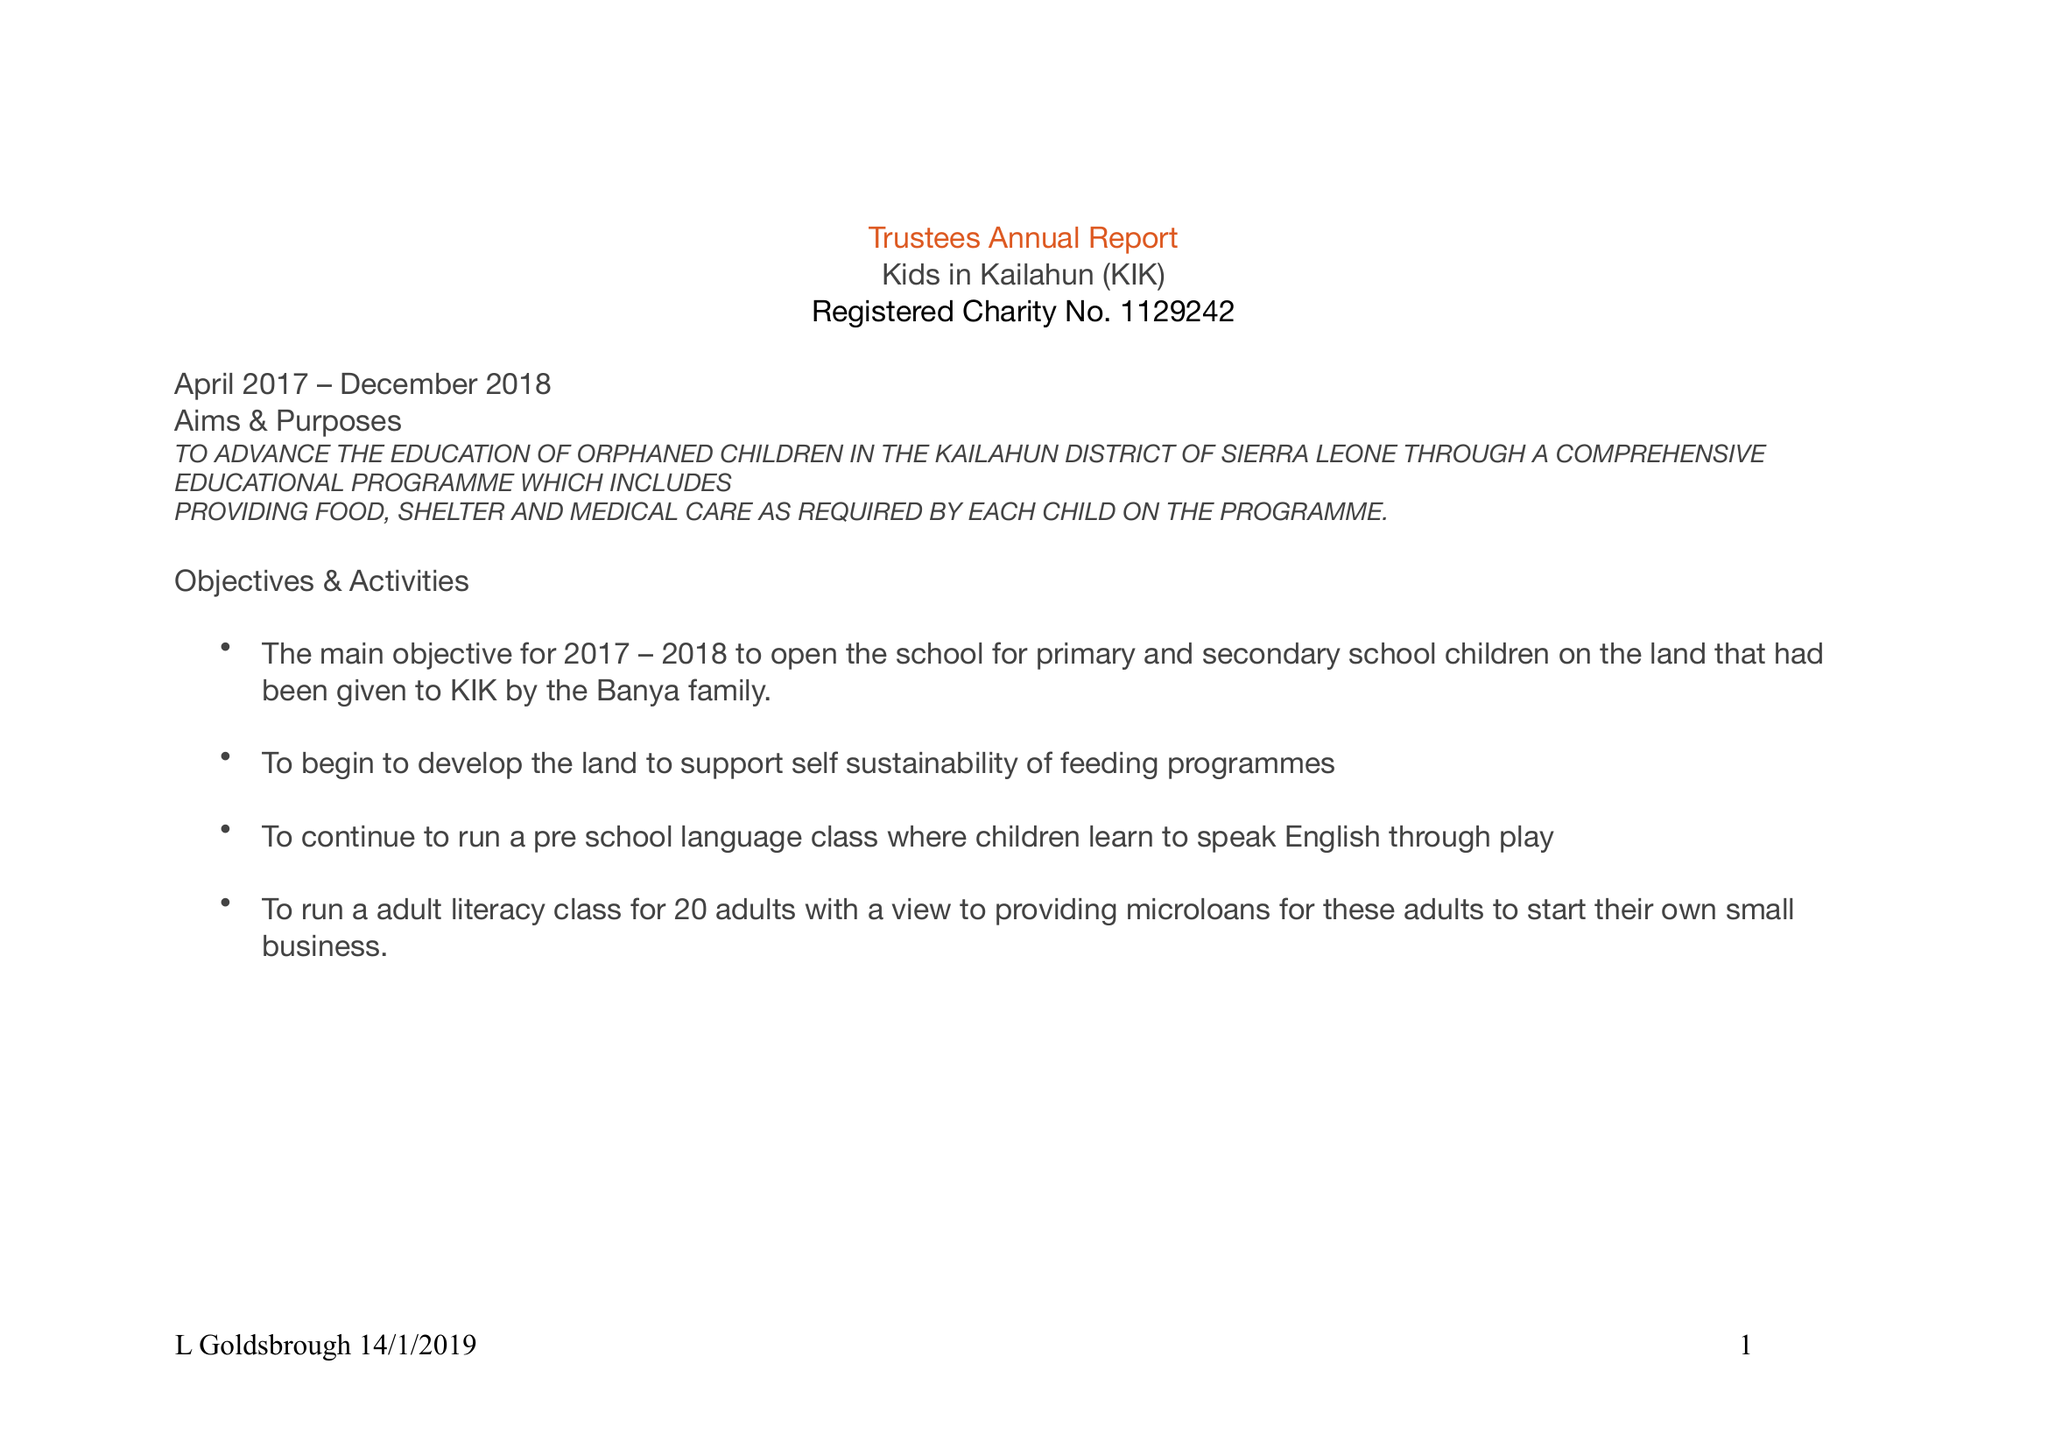What is the value for the spending_annually_in_british_pounds?
Answer the question using a single word or phrase. 35330.00 